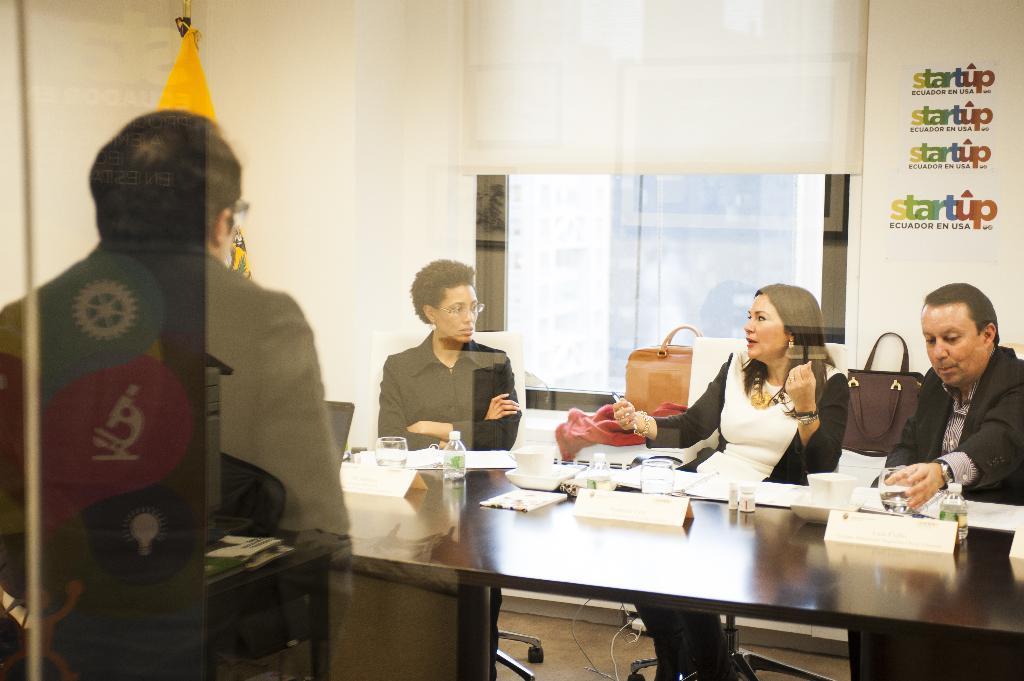Can you describe this image briefly? There are 2 women and 2 men in this room. On the right 2nd woman is sitting and talking. We can also see a table. On the table bottles,papers,glasses,etc. In the background there is a window,curtain,wall and handbags. 